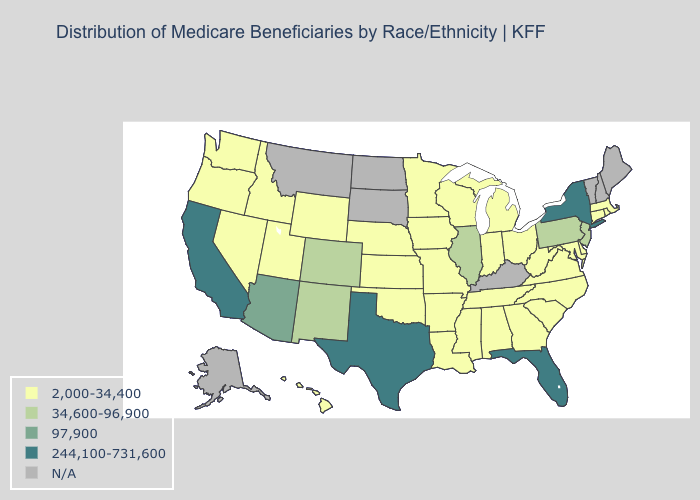What is the value of Kansas?
Short answer required. 2,000-34,400. What is the value of Wyoming?
Give a very brief answer. 2,000-34,400. Name the states that have a value in the range N/A?
Keep it brief. Alaska, Kentucky, Maine, Montana, New Hampshire, North Dakota, South Dakota, Vermont. Which states have the lowest value in the USA?
Be succinct. Alabama, Arkansas, Connecticut, Delaware, Georgia, Hawaii, Idaho, Indiana, Iowa, Kansas, Louisiana, Maryland, Massachusetts, Michigan, Minnesota, Mississippi, Missouri, Nebraska, Nevada, North Carolina, Ohio, Oklahoma, Oregon, Rhode Island, South Carolina, Tennessee, Utah, Virginia, Washington, West Virginia, Wisconsin, Wyoming. Is the legend a continuous bar?
Answer briefly. No. What is the value of Mississippi?
Short answer required. 2,000-34,400. Among the states that border New Jersey , which have the lowest value?
Give a very brief answer. Delaware. What is the value of New York?
Give a very brief answer. 244,100-731,600. What is the value of Rhode Island?
Short answer required. 2,000-34,400. What is the lowest value in the USA?
Answer briefly. 2,000-34,400. What is the value of Alaska?
Concise answer only. N/A. Is the legend a continuous bar?
Be succinct. No. Which states hav the highest value in the South?
Keep it brief. Florida, Texas. 